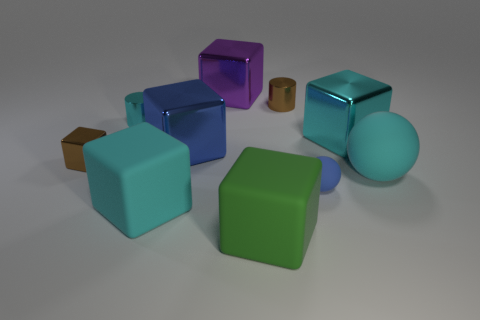What is the material of the brown cylinder?
Provide a succinct answer. Metal. Is the large cyan thing to the left of the green object made of the same material as the large cyan thing that is behind the large blue object?
Keep it short and to the point. No. Are there any other things that are the same color as the big ball?
Give a very brief answer. Yes. What is the color of the small object that is the same shape as the big green object?
Your answer should be very brief. Brown. There is a cyan object that is both behind the cyan rubber sphere and on the right side of the cyan cylinder; what size is it?
Keep it short and to the point. Large. There is a tiny shiny thing on the right side of the green object; is it the same shape as the cyan object that is left of the cyan matte block?
Keep it short and to the point. Yes. What is the shape of the small object that is the same color as the tiny metallic cube?
Keep it short and to the point. Cylinder. What number of green cubes have the same material as the big purple cube?
Ensure brevity in your answer.  0. There is a tiny metal object that is both behind the small brown block and to the left of the big cyan matte block; what shape is it?
Your response must be concise. Cylinder. Is the material of the large cyan block that is to the right of the big cyan rubber block the same as the cyan sphere?
Offer a very short reply. No. 